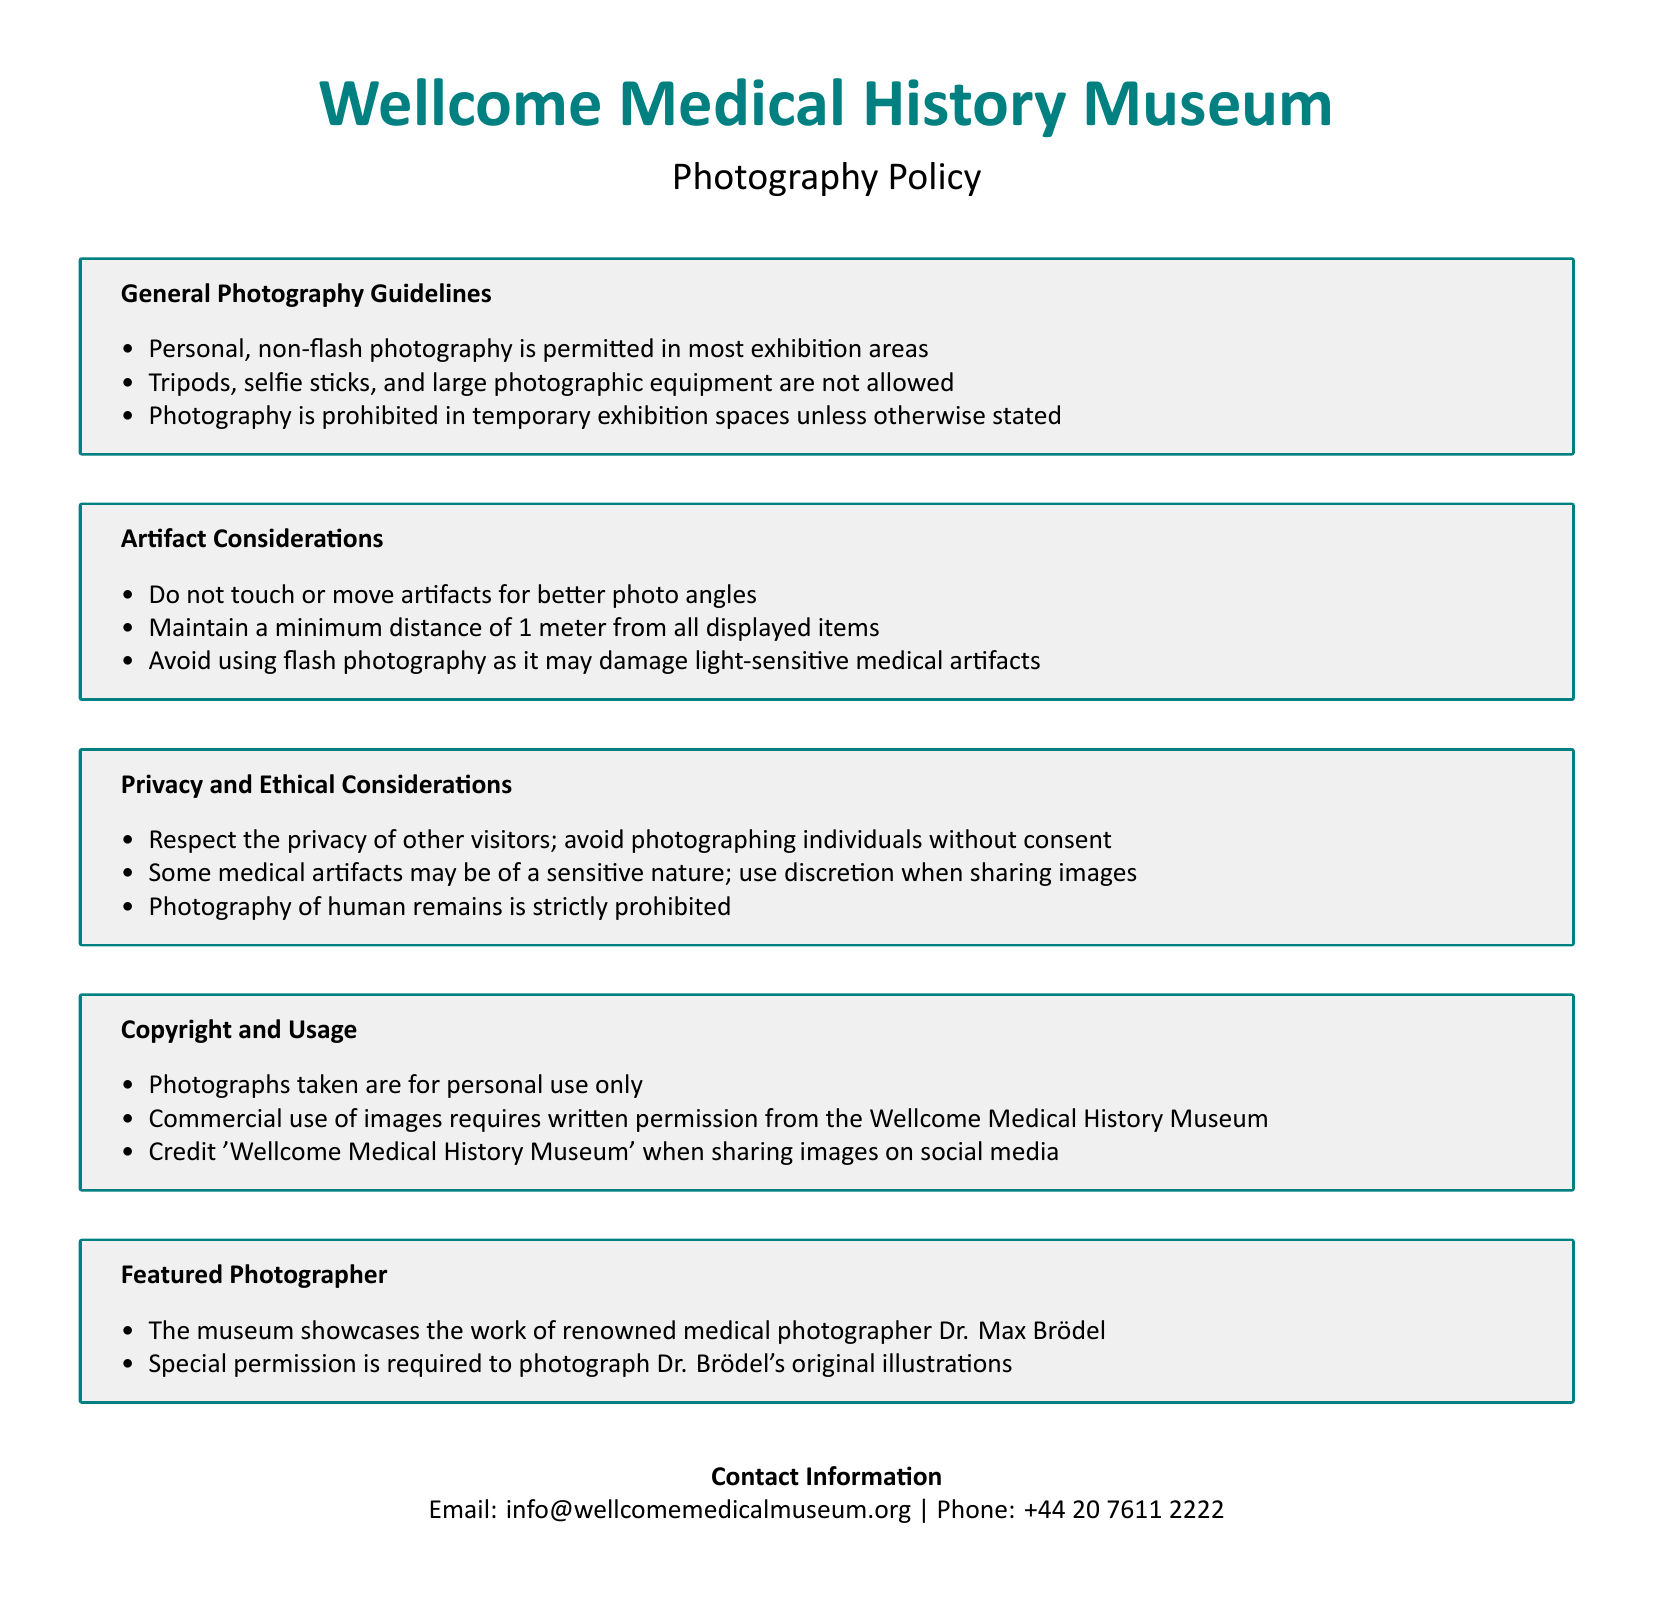What is the museum's name? The museum's name is stated at the beginning of the policy document as "Wellcome Medical History Museum."
Answer: Wellcome Medical History Museum Is flash photography allowed? The general photography guidelines section specifies that flash photography is prohibited, particularly to avoid damage to artifacts.
Answer: No What is the minimum distance from artifacts? The document mentions a minimum distance requirement from displayed items for photography.
Answer: 1 meter Who is the featured photographer? The section on featured photographers provides the name of the renowned medical photographer showcased by the museum.
Answer: Dr. Max Brödel What must you do when sharing images on social media? The copyright and usage section advises what to include when sharing images on social media.
Answer: Credit 'Wellcome Medical History Museum' Are tripods allowed in the museum? The guidelines specify what equipment visitors can bring for photography, clearly stating the rules about tripods.
Answer: No What type of photography is prohibited in temporary exhibition spaces? The guidelines under the general photography section express restrictions related to different exhibition areas specifically.
Answer: Photography What is required for commercial use of images? The copyright and usage section outlines what is necessary for commercial usage of photographs taken in the museum.
Answer: Written permission What should visitors avoid when photographing other individuals? The privacy and ethical considerations section highlights the importance of consent regarding photography of individuals.
Answer: Photographing individuals without consent 